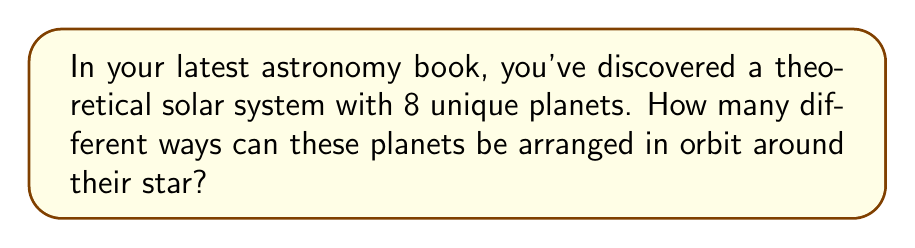Help me with this question. Let's approach this step-by-step:

1) This problem is a perfect example of a permutation. We're arranging all 8 planets in different orders, and each planet can only be used once.

2) The formula for permutations of n distinct objects is:

   $$P_n = n!$$

   Where n! (n factorial) is the product of all positive integers less than or equal to n.

3) In this case, n = 8 (as there are 8 planets).

4) So, we need to calculate 8!:

   $$8! = 8 \times 7 \times 6 \times 5 \times 4 \times 3 \times 2 \times 1$$

5) Let's multiply this out:

   $$8! = 40,320$$

Therefore, there are 40,320 different ways to arrange 8 planets in this theoretical solar system.
Answer: 40,320 